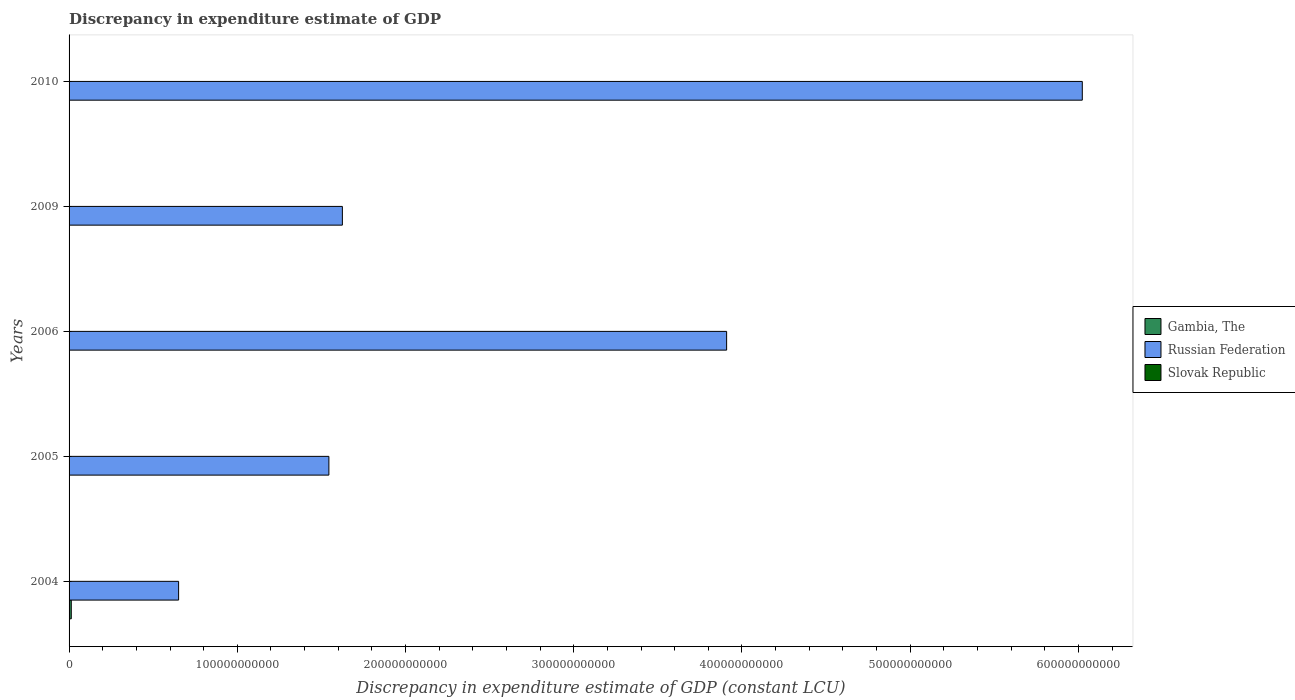Are the number of bars on each tick of the Y-axis equal?
Offer a terse response. No. In how many cases, is the number of bars for a given year not equal to the number of legend labels?
Provide a succinct answer. 3. What is the discrepancy in expenditure estimate of GDP in Russian Federation in 2009?
Your response must be concise. 1.62e+11. Across all years, what is the maximum discrepancy in expenditure estimate of GDP in Russian Federation?
Keep it short and to the point. 6.02e+11. What is the total discrepancy in expenditure estimate of GDP in Russian Federation in the graph?
Give a very brief answer. 1.38e+12. What is the difference between the discrepancy in expenditure estimate of GDP in Gambia, The in 2006 and that in 2010?
Your answer should be compact. -6.08e+07. What is the difference between the discrepancy in expenditure estimate of GDP in Slovak Republic in 2010 and the discrepancy in expenditure estimate of GDP in Gambia, The in 2009?
Provide a short and direct response. 7.62939453125e-6. What is the average discrepancy in expenditure estimate of GDP in Gambia, The per year?
Your answer should be compact. 2.75e+08. In the year 2010, what is the difference between the discrepancy in expenditure estimate of GDP in Russian Federation and discrepancy in expenditure estimate of GDP in Slovak Republic?
Your answer should be very brief. 6.02e+11. What is the ratio of the discrepancy in expenditure estimate of GDP in Gambia, The in 2004 to that in 2005?
Provide a succinct answer. 1.31e+07. Is the discrepancy in expenditure estimate of GDP in Russian Federation in 2005 less than that in 2006?
Offer a very short reply. Yes. What is the difference between the highest and the second highest discrepancy in expenditure estimate of GDP in Russian Federation?
Your answer should be compact. 2.11e+11. What is the difference between the highest and the lowest discrepancy in expenditure estimate of GDP in Gambia, The?
Give a very brief answer. 1.31e+09. Is it the case that in every year, the sum of the discrepancy in expenditure estimate of GDP in Russian Federation and discrepancy in expenditure estimate of GDP in Gambia, The is greater than the discrepancy in expenditure estimate of GDP in Slovak Republic?
Your answer should be compact. Yes. How many bars are there?
Offer a very short reply. 11. How many years are there in the graph?
Provide a succinct answer. 5. What is the difference between two consecutive major ticks on the X-axis?
Your response must be concise. 1.00e+11. Does the graph contain any zero values?
Provide a short and direct response. Yes. How are the legend labels stacked?
Keep it short and to the point. Vertical. What is the title of the graph?
Offer a very short reply. Discrepancy in expenditure estimate of GDP. What is the label or title of the X-axis?
Give a very brief answer. Discrepancy in expenditure estimate of GDP (constant LCU). What is the Discrepancy in expenditure estimate of GDP (constant LCU) in Gambia, The in 2004?
Your answer should be compact. 1.31e+09. What is the Discrepancy in expenditure estimate of GDP (constant LCU) in Russian Federation in 2004?
Your response must be concise. 6.51e+1. What is the Discrepancy in expenditure estimate of GDP (constant LCU) in Gambia, The in 2005?
Offer a very short reply. 100. What is the Discrepancy in expenditure estimate of GDP (constant LCU) in Russian Federation in 2005?
Provide a succinct answer. 1.54e+11. What is the Discrepancy in expenditure estimate of GDP (constant LCU) of Slovak Republic in 2005?
Make the answer very short. 0. What is the Discrepancy in expenditure estimate of GDP (constant LCU) in Gambia, The in 2006?
Ensure brevity in your answer.  100. What is the Discrepancy in expenditure estimate of GDP (constant LCU) in Russian Federation in 2006?
Offer a terse response. 3.91e+11. What is the Discrepancy in expenditure estimate of GDP (constant LCU) of Slovak Republic in 2006?
Give a very brief answer. 7.35e+07. What is the Discrepancy in expenditure estimate of GDP (constant LCU) in Russian Federation in 2009?
Your answer should be very brief. 1.62e+11. What is the Discrepancy in expenditure estimate of GDP (constant LCU) of Slovak Republic in 2009?
Your answer should be very brief. 0. What is the Discrepancy in expenditure estimate of GDP (constant LCU) in Gambia, The in 2010?
Provide a succinct answer. 6.08e+07. What is the Discrepancy in expenditure estimate of GDP (constant LCU) of Russian Federation in 2010?
Your response must be concise. 6.02e+11. What is the Discrepancy in expenditure estimate of GDP (constant LCU) in Slovak Republic in 2010?
Provide a succinct answer. 7.62939453125e-6. Across all years, what is the maximum Discrepancy in expenditure estimate of GDP (constant LCU) in Gambia, The?
Offer a very short reply. 1.31e+09. Across all years, what is the maximum Discrepancy in expenditure estimate of GDP (constant LCU) of Russian Federation?
Your response must be concise. 6.02e+11. Across all years, what is the maximum Discrepancy in expenditure estimate of GDP (constant LCU) of Slovak Republic?
Ensure brevity in your answer.  7.35e+07. Across all years, what is the minimum Discrepancy in expenditure estimate of GDP (constant LCU) of Russian Federation?
Offer a very short reply. 6.51e+1. What is the total Discrepancy in expenditure estimate of GDP (constant LCU) in Gambia, The in the graph?
Provide a succinct answer. 1.37e+09. What is the total Discrepancy in expenditure estimate of GDP (constant LCU) in Russian Federation in the graph?
Ensure brevity in your answer.  1.38e+12. What is the total Discrepancy in expenditure estimate of GDP (constant LCU) in Slovak Republic in the graph?
Your answer should be very brief. 7.35e+07. What is the difference between the Discrepancy in expenditure estimate of GDP (constant LCU) in Gambia, The in 2004 and that in 2005?
Give a very brief answer. 1.31e+09. What is the difference between the Discrepancy in expenditure estimate of GDP (constant LCU) in Russian Federation in 2004 and that in 2005?
Your answer should be very brief. -8.93e+1. What is the difference between the Discrepancy in expenditure estimate of GDP (constant LCU) of Gambia, The in 2004 and that in 2006?
Provide a short and direct response. 1.31e+09. What is the difference between the Discrepancy in expenditure estimate of GDP (constant LCU) of Russian Federation in 2004 and that in 2006?
Give a very brief answer. -3.26e+11. What is the difference between the Discrepancy in expenditure estimate of GDP (constant LCU) of Russian Federation in 2004 and that in 2009?
Your answer should be compact. -9.74e+1. What is the difference between the Discrepancy in expenditure estimate of GDP (constant LCU) of Gambia, The in 2004 and that in 2010?
Provide a short and direct response. 1.25e+09. What is the difference between the Discrepancy in expenditure estimate of GDP (constant LCU) in Russian Federation in 2004 and that in 2010?
Make the answer very short. -5.37e+11. What is the difference between the Discrepancy in expenditure estimate of GDP (constant LCU) of Russian Federation in 2005 and that in 2006?
Offer a very short reply. -2.36e+11. What is the difference between the Discrepancy in expenditure estimate of GDP (constant LCU) of Russian Federation in 2005 and that in 2009?
Offer a terse response. -8.01e+09. What is the difference between the Discrepancy in expenditure estimate of GDP (constant LCU) in Gambia, The in 2005 and that in 2010?
Provide a short and direct response. -6.08e+07. What is the difference between the Discrepancy in expenditure estimate of GDP (constant LCU) of Russian Federation in 2005 and that in 2010?
Offer a terse response. -4.48e+11. What is the difference between the Discrepancy in expenditure estimate of GDP (constant LCU) of Russian Federation in 2006 and that in 2009?
Provide a succinct answer. 2.28e+11. What is the difference between the Discrepancy in expenditure estimate of GDP (constant LCU) of Gambia, The in 2006 and that in 2010?
Your answer should be very brief. -6.08e+07. What is the difference between the Discrepancy in expenditure estimate of GDP (constant LCU) of Russian Federation in 2006 and that in 2010?
Offer a very short reply. -2.11e+11. What is the difference between the Discrepancy in expenditure estimate of GDP (constant LCU) in Slovak Republic in 2006 and that in 2010?
Offer a very short reply. 7.35e+07. What is the difference between the Discrepancy in expenditure estimate of GDP (constant LCU) in Russian Federation in 2009 and that in 2010?
Offer a terse response. -4.40e+11. What is the difference between the Discrepancy in expenditure estimate of GDP (constant LCU) of Gambia, The in 2004 and the Discrepancy in expenditure estimate of GDP (constant LCU) of Russian Federation in 2005?
Make the answer very short. -1.53e+11. What is the difference between the Discrepancy in expenditure estimate of GDP (constant LCU) in Gambia, The in 2004 and the Discrepancy in expenditure estimate of GDP (constant LCU) in Russian Federation in 2006?
Your answer should be very brief. -3.90e+11. What is the difference between the Discrepancy in expenditure estimate of GDP (constant LCU) of Gambia, The in 2004 and the Discrepancy in expenditure estimate of GDP (constant LCU) of Slovak Republic in 2006?
Make the answer very short. 1.24e+09. What is the difference between the Discrepancy in expenditure estimate of GDP (constant LCU) in Russian Federation in 2004 and the Discrepancy in expenditure estimate of GDP (constant LCU) in Slovak Republic in 2006?
Your response must be concise. 6.50e+1. What is the difference between the Discrepancy in expenditure estimate of GDP (constant LCU) in Gambia, The in 2004 and the Discrepancy in expenditure estimate of GDP (constant LCU) in Russian Federation in 2009?
Offer a very short reply. -1.61e+11. What is the difference between the Discrepancy in expenditure estimate of GDP (constant LCU) of Gambia, The in 2004 and the Discrepancy in expenditure estimate of GDP (constant LCU) of Russian Federation in 2010?
Keep it short and to the point. -6.01e+11. What is the difference between the Discrepancy in expenditure estimate of GDP (constant LCU) of Gambia, The in 2004 and the Discrepancy in expenditure estimate of GDP (constant LCU) of Slovak Republic in 2010?
Keep it short and to the point. 1.31e+09. What is the difference between the Discrepancy in expenditure estimate of GDP (constant LCU) of Russian Federation in 2004 and the Discrepancy in expenditure estimate of GDP (constant LCU) of Slovak Republic in 2010?
Offer a very short reply. 6.51e+1. What is the difference between the Discrepancy in expenditure estimate of GDP (constant LCU) in Gambia, The in 2005 and the Discrepancy in expenditure estimate of GDP (constant LCU) in Russian Federation in 2006?
Keep it short and to the point. -3.91e+11. What is the difference between the Discrepancy in expenditure estimate of GDP (constant LCU) in Gambia, The in 2005 and the Discrepancy in expenditure estimate of GDP (constant LCU) in Slovak Republic in 2006?
Provide a short and direct response. -7.35e+07. What is the difference between the Discrepancy in expenditure estimate of GDP (constant LCU) in Russian Federation in 2005 and the Discrepancy in expenditure estimate of GDP (constant LCU) in Slovak Republic in 2006?
Your answer should be very brief. 1.54e+11. What is the difference between the Discrepancy in expenditure estimate of GDP (constant LCU) of Gambia, The in 2005 and the Discrepancy in expenditure estimate of GDP (constant LCU) of Russian Federation in 2009?
Make the answer very short. -1.62e+11. What is the difference between the Discrepancy in expenditure estimate of GDP (constant LCU) in Gambia, The in 2005 and the Discrepancy in expenditure estimate of GDP (constant LCU) in Russian Federation in 2010?
Offer a terse response. -6.02e+11. What is the difference between the Discrepancy in expenditure estimate of GDP (constant LCU) of Gambia, The in 2005 and the Discrepancy in expenditure estimate of GDP (constant LCU) of Slovak Republic in 2010?
Give a very brief answer. 100. What is the difference between the Discrepancy in expenditure estimate of GDP (constant LCU) in Russian Federation in 2005 and the Discrepancy in expenditure estimate of GDP (constant LCU) in Slovak Republic in 2010?
Ensure brevity in your answer.  1.54e+11. What is the difference between the Discrepancy in expenditure estimate of GDP (constant LCU) of Gambia, The in 2006 and the Discrepancy in expenditure estimate of GDP (constant LCU) of Russian Federation in 2009?
Keep it short and to the point. -1.62e+11. What is the difference between the Discrepancy in expenditure estimate of GDP (constant LCU) of Gambia, The in 2006 and the Discrepancy in expenditure estimate of GDP (constant LCU) of Russian Federation in 2010?
Your answer should be compact. -6.02e+11. What is the difference between the Discrepancy in expenditure estimate of GDP (constant LCU) in Russian Federation in 2006 and the Discrepancy in expenditure estimate of GDP (constant LCU) in Slovak Republic in 2010?
Offer a terse response. 3.91e+11. What is the difference between the Discrepancy in expenditure estimate of GDP (constant LCU) in Russian Federation in 2009 and the Discrepancy in expenditure estimate of GDP (constant LCU) in Slovak Republic in 2010?
Provide a short and direct response. 1.62e+11. What is the average Discrepancy in expenditure estimate of GDP (constant LCU) in Gambia, The per year?
Your response must be concise. 2.75e+08. What is the average Discrepancy in expenditure estimate of GDP (constant LCU) in Russian Federation per year?
Make the answer very short. 2.75e+11. What is the average Discrepancy in expenditure estimate of GDP (constant LCU) in Slovak Republic per year?
Give a very brief answer. 1.47e+07. In the year 2004, what is the difference between the Discrepancy in expenditure estimate of GDP (constant LCU) in Gambia, The and Discrepancy in expenditure estimate of GDP (constant LCU) in Russian Federation?
Give a very brief answer. -6.38e+1. In the year 2005, what is the difference between the Discrepancy in expenditure estimate of GDP (constant LCU) in Gambia, The and Discrepancy in expenditure estimate of GDP (constant LCU) in Russian Federation?
Provide a succinct answer. -1.54e+11. In the year 2006, what is the difference between the Discrepancy in expenditure estimate of GDP (constant LCU) of Gambia, The and Discrepancy in expenditure estimate of GDP (constant LCU) of Russian Federation?
Offer a very short reply. -3.91e+11. In the year 2006, what is the difference between the Discrepancy in expenditure estimate of GDP (constant LCU) of Gambia, The and Discrepancy in expenditure estimate of GDP (constant LCU) of Slovak Republic?
Give a very brief answer. -7.35e+07. In the year 2006, what is the difference between the Discrepancy in expenditure estimate of GDP (constant LCU) of Russian Federation and Discrepancy in expenditure estimate of GDP (constant LCU) of Slovak Republic?
Give a very brief answer. 3.91e+11. In the year 2010, what is the difference between the Discrepancy in expenditure estimate of GDP (constant LCU) of Gambia, The and Discrepancy in expenditure estimate of GDP (constant LCU) of Russian Federation?
Keep it short and to the point. -6.02e+11. In the year 2010, what is the difference between the Discrepancy in expenditure estimate of GDP (constant LCU) in Gambia, The and Discrepancy in expenditure estimate of GDP (constant LCU) in Slovak Republic?
Your answer should be compact. 6.08e+07. In the year 2010, what is the difference between the Discrepancy in expenditure estimate of GDP (constant LCU) of Russian Federation and Discrepancy in expenditure estimate of GDP (constant LCU) of Slovak Republic?
Ensure brevity in your answer.  6.02e+11. What is the ratio of the Discrepancy in expenditure estimate of GDP (constant LCU) in Gambia, The in 2004 to that in 2005?
Give a very brief answer. 1.31e+07. What is the ratio of the Discrepancy in expenditure estimate of GDP (constant LCU) in Russian Federation in 2004 to that in 2005?
Ensure brevity in your answer.  0.42. What is the ratio of the Discrepancy in expenditure estimate of GDP (constant LCU) of Gambia, The in 2004 to that in 2006?
Make the answer very short. 1.31e+07. What is the ratio of the Discrepancy in expenditure estimate of GDP (constant LCU) in Russian Federation in 2004 to that in 2006?
Give a very brief answer. 0.17. What is the ratio of the Discrepancy in expenditure estimate of GDP (constant LCU) of Russian Federation in 2004 to that in 2009?
Give a very brief answer. 0.4. What is the ratio of the Discrepancy in expenditure estimate of GDP (constant LCU) in Gambia, The in 2004 to that in 2010?
Your answer should be compact. 21.62. What is the ratio of the Discrepancy in expenditure estimate of GDP (constant LCU) of Russian Federation in 2004 to that in 2010?
Make the answer very short. 0.11. What is the ratio of the Discrepancy in expenditure estimate of GDP (constant LCU) of Russian Federation in 2005 to that in 2006?
Offer a very short reply. 0.4. What is the ratio of the Discrepancy in expenditure estimate of GDP (constant LCU) in Russian Federation in 2005 to that in 2009?
Offer a very short reply. 0.95. What is the ratio of the Discrepancy in expenditure estimate of GDP (constant LCU) in Gambia, The in 2005 to that in 2010?
Make the answer very short. 0. What is the ratio of the Discrepancy in expenditure estimate of GDP (constant LCU) of Russian Federation in 2005 to that in 2010?
Your answer should be compact. 0.26. What is the ratio of the Discrepancy in expenditure estimate of GDP (constant LCU) in Russian Federation in 2006 to that in 2009?
Provide a short and direct response. 2.41. What is the ratio of the Discrepancy in expenditure estimate of GDP (constant LCU) in Russian Federation in 2006 to that in 2010?
Give a very brief answer. 0.65. What is the ratio of the Discrepancy in expenditure estimate of GDP (constant LCU) of Slovak Republic in 2006 to that in 2010?
Your answer should be very brief. 9.63e+12. What is the ratio of the Discrepancy in expenditure estimate of GDP (constant LCU) of Russian Federation in 2009 to that in 2010?
Ensure brevity in your answer.  0.27. What is the difference between the highest and the second highest Discrepancy in expenditure estimate of GDP (constant LCU) of Gambia, The?
Your response must be concise. 1.25e+09. What is the difference between the highest and the second highest Discrepancy in expenditure estimate of GDP (constant LCU) of Russian Federation?
Your response must be concise. 2.11e+11. What is the difference between the highest and the lowest Discrepancy in expenditure estimate of GDP (constant LCU) of Gambia, The?
Your answer should be compact. 1.31e+09. What is the difference between the highest and the lowest Discrepancy in expenditure estimate of GDP (constant LCU) of Russian Federation?
Keep it short and to the point. 5.37e+11. What is the difference between the highest and the lowest Discrepancy in expenditure estimate of GDP (constant LCU) in Slovak Republic?
Give a very brief answer. 7.35e+07. 